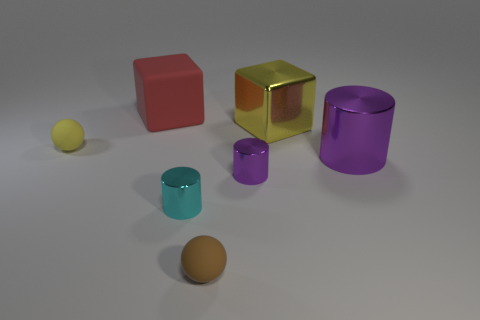Add 3 yellow spheres. How many objects exist? 10 Subtract all cylinders. How many objects are left? 4 Add 4 big things. How many big things exist? 7 Subtract 0 brown cylinders. How many objects are left? 7 Subtract all small green spheres. Subtract all purple metal objects. How many objects are left? 5 Add 1 brown spheres. How many brown spheres are left? 2 